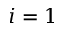<formula> <loc_0><loc_0><loc_500><loc_500>i = 1</formula> 